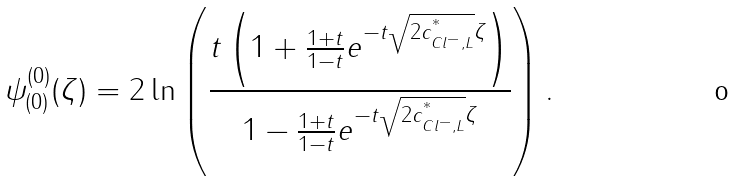<formula> <loc_0><loc_0><loc_500><loc_500>\psi ^ { ( 0 ) } _ { ( 0 ) } ( \zeta ) = 2 \ln \left ( \frac { t \left ( 1 + \frac { 1 + t } { 1 - t } e ^ { - t \sqrt { 2 c ^ { ^ { * } } _ { C l ^ { - } , L } } \zeta } \right ) } { 1 - \frac { 1 + t } { 1 - t } e ^ { - t \sqrt { 2 c ^ { ^ { * } } _ { C l ^ { - } , L } } \zeta } } \right ) .</formula> 